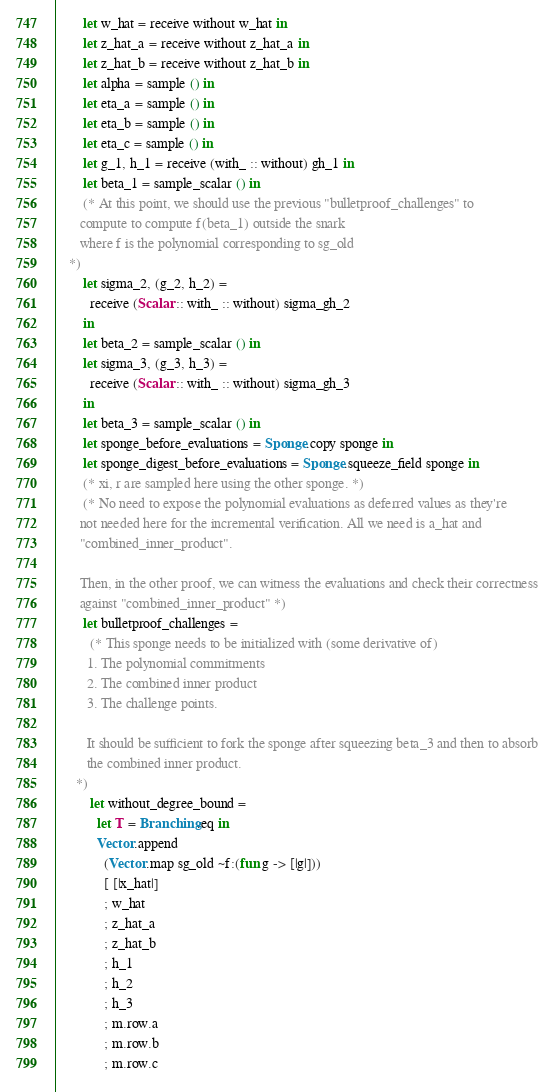<code> <loc_0><loc_0><loc_500><loc_500><_OCaml_>        let w_hat = receive without w_hat in
        let z_hat_a = receive without z_hat_a in
        let z_hat_b = receive without z_hat_b in
        let alpha = sample () in
        let eta_a = sample () in
        let eta_b = sample () in
        let eta_c = sample () in
        let g_1, h_1 = receive (with_ :: without) gh_1 in
        let beta_1 = sample_scalar () in
        (* At this point, we should use the previous "bulletproof_challenges" to
       compute to compute f(beta_1) outside the snark
       where f is the polynomial corresponding to sg_old
    *)
        let sigma_2, (g_2, h_2) =
          receive (Scalar :: with_ :: without) sigma_gh_2
        in
        let beta_2 = sample_scalar () in
        let sigma_3, (g_3, h_3) =
          receive (Scalar :: with_ :: without) sigma_gh_3
        in
        let beta_3 = sample_scalar () in
        let sponge_before_evaluations = Sponge.copy sponge in
        let sponge_digest_before_evaluations = Sponge.squeeze_field sponge in
        (* xi, r are sampled here using the other sponge. *)
        (* No need to expose the polynomial evaluations as deferred values as they're
       not needed here for the incremental verification. All we need is a_hat and
       "combined_inner_product".

       Then, in the other proof, we can witness the evaluations and check their correctness
       against "combined_inner_product" *)
        let bulletproof_challenges =
          (* This sponge needs to be initialized with (some derivative of)
         1. The polynomial commitments
         2. The combined inner product
         3. The challenge points.

         It should be sufficient to fork the sponge after squeezing beta_3 and then to absorb
         the combined inner product.
      *)
          let without_degree_bound =
            let T = Branching.eq in
            Vector.append
              (Vector.map sg_old ~f:(fun g -> [|g|]))
              [ [|x_hat|]
              ; w_hat
              ; z_hat_a
              ; z_hat_b
              ; h_1
              ; h_2
              ; h_3
              ; m.row.a
              ; m.row.b
              ; m.row.c</code> 